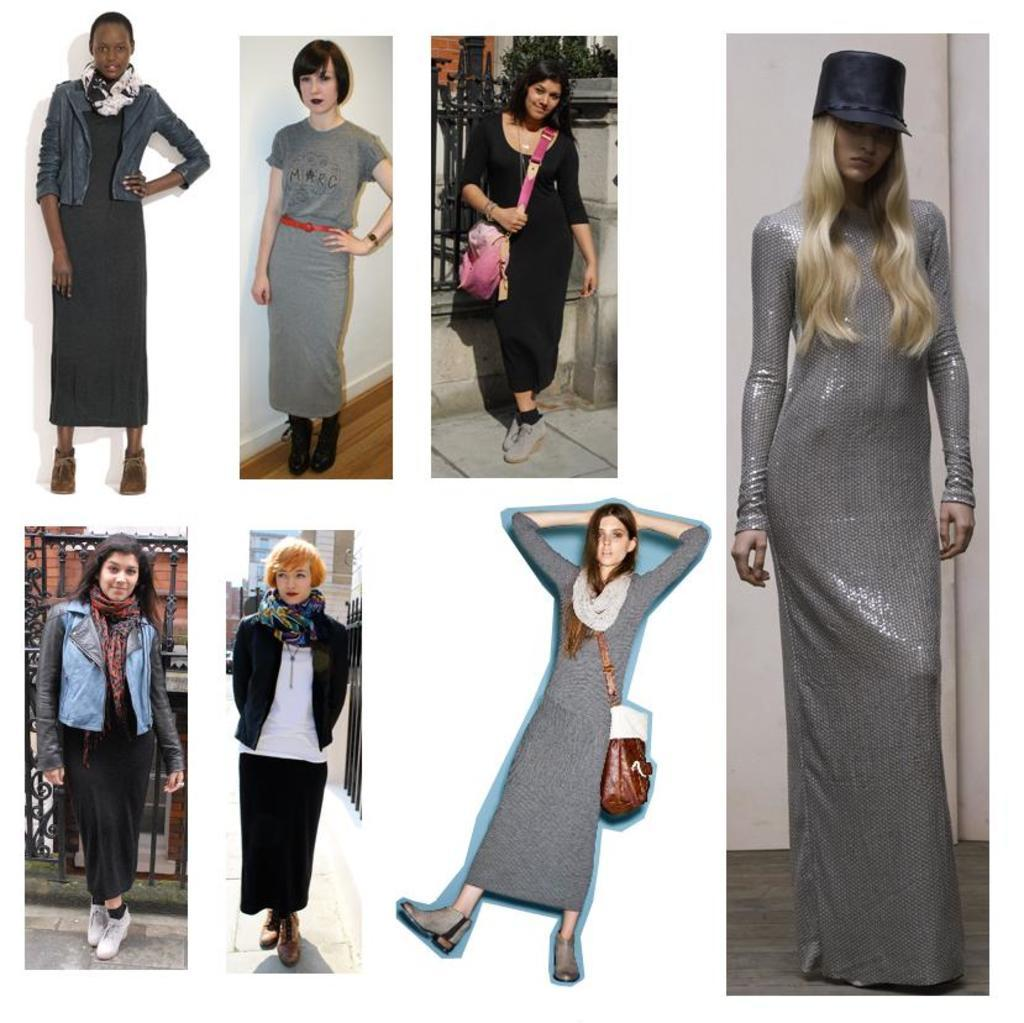What type of artwork is depicted in the image? The image is a collage. What subjects are featured in the collage? There are women in the collage. What are the women doing in the collage? The women are standing. What type of oven is visible in the collage? There is no oven present in the collage; it features women standing. What role does the son play in the collage? There is no mention of a son in the collage; it only features women standing. 